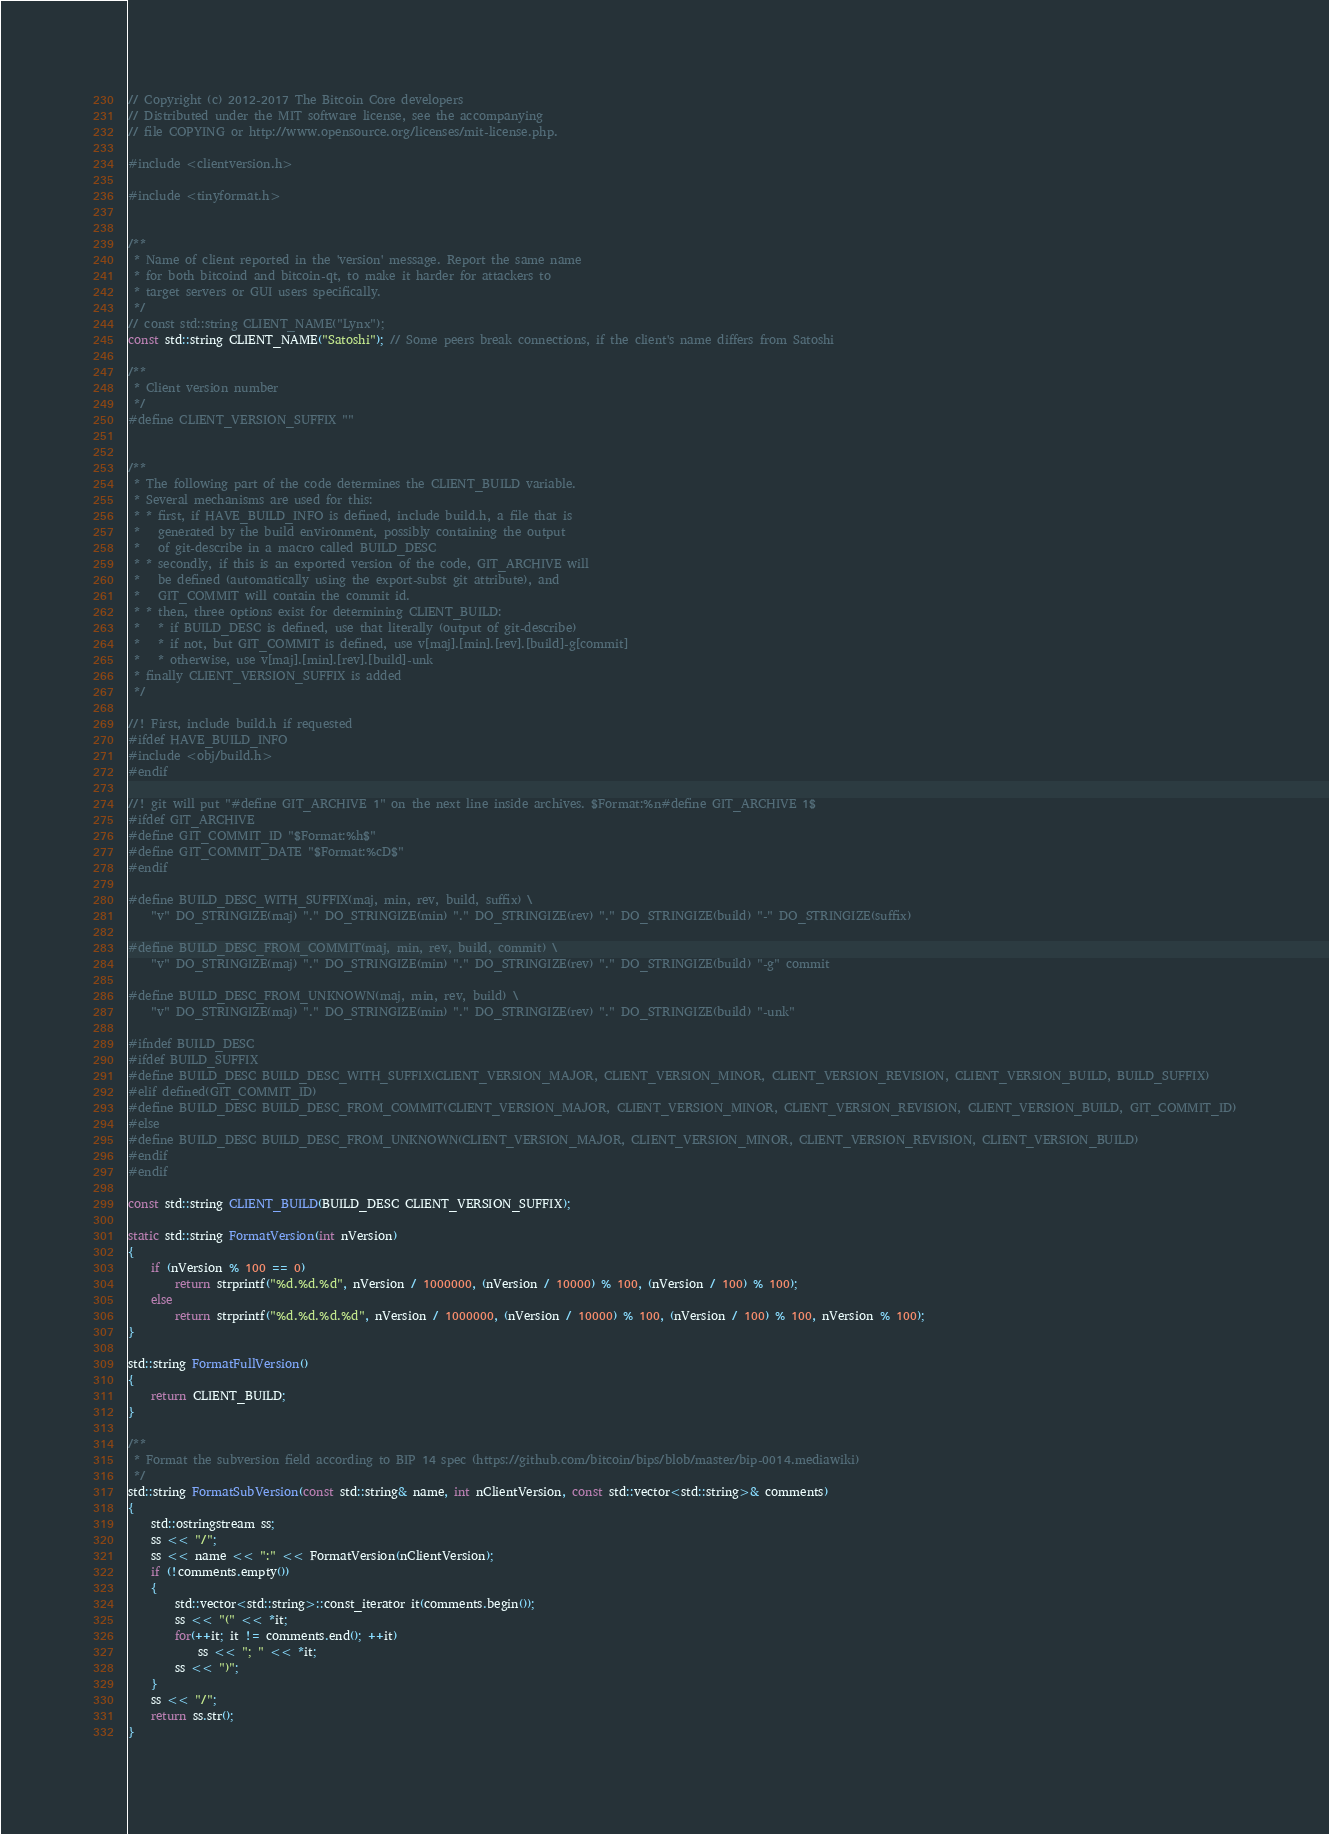<code> <loc_0><loc_0><loc_500><loc_500><_C++_>// Copyright (c) 2012-2017 The Bitcoin Core developers
// Distributed under the MIT software license, see the accompanying
// file COPYING or http://www.opensource.org/licenses/mit-license.php.

#include <clientversion.h>

#include <tinyformat.h>


/**
 * Name of client reported in the 'version' message. Report the same name
 * for both bitcoind and bitcoin-qt, to make it harder for attackers to
 * target servers or GUI users specifically.
 */
// const std::string CLIENT_NAME("Lynx");
const std::string CLIENT_NAME("Satoshi"); // Some peers break connections, if the client's name differs from Satoshi

/**
 * Client version number
 */
#define CLIENT_VERSION_SUFFIX ""


/**
 * The following part of the code determines the CLIENT_BUILD variable.
 * Several mechanisms are used for this:
 * * first, if HAVE_BUILD_INFO is defined, include build.h, a file that is
 *   generated by the build environment, possibly containing the output
 *   of git-describe in a macro called BUILD_DESC
 * * secondly, if this is an exported version of the code, GIT_ARCHIVE will
 *   be defined (automatically using the export-subst git attribute), and
 *   GIT_COMMIT will contain the commit id.
 * * then, three options exist for determining CLIENT_BUILD:
 *   * if BUILD_DESC is defined, use that literally (output of git-describe)
 *   * if not, but GIT_COMMIT is defined, use v[maj].[min].[rev].[build]-g[commit]
 *   * otherwise, use v[maj].[min].[rev].[build]-unk
 * finally CLIENT_VERSION_SUFFIX is added
 */

//! First, include build.h if requested
#ifdef HAVE_BUILD_INFO
#include <obj/build.h>
#endif

//! git will put "#define GIT_ARCHIVE 1" on the next line inside archives. $Format:%n#define GIT_ARCHIVE 1$
#ifdef GIT_ARCHIVE
#define GIT_COMMIT_ID "$Format:%h$"
#define GIT_COMMIT_DATE "$Format:%cD$"
#endif

#define BUILD_DESC_WITH_SUFFIX(maj, min, rev, build, suffix) \
    "v" DO_STRINGIZE(maj) "." DO_STRINGIZE(min) "." DO_STRINGIZE(rev) "." DO_STRINGIZE(build) "-" DO_STRINGIZE(suffix)

#define BUILD_DESC_FROM_COMMIT(maj, min, rev, build, commit) \
    "v" DO_STRINGIZE(maj) "." DO_STRINGIZE(min) "." DO_STRINGIZE(rev) "." DO_STRINGIZE(build) "-g" commit

#define BUILD_DESC_FROM_UNKNOWN(maj, min, rev, build) \
    "v" DO_STRINGIZE(maj) "." DO_STRINGIZE(min) "." DO_STRINGIZE(rev) "." DO_STRINGIZE(build) "-unk"

#ifndef BUILD_DESC
#ifdef BUILD_SUFFIX
#define BUILD_DESC BUILD_DESC_WITH_SUFFIX(CLIENT_VERSION_MAJOR, CLIENT_VERSION_MINOR, CLIENT_VERSION_REVISION, CLIENT_VERSION_BUILD, BUILD_SUFFIX)
#elif defined(GIT_COMMIT_ID)
#define BUILD_DESC BUILD_DESC_FROM_COMMIT(CLIENT_VERSION_MAJOR, CLIENT_VERSION_MINOR, CLIENT_VERSION_REVISION, CLIENT_VERSION_BUILD, GIT_COMMIT_ID)
#else
#define BUILD_DESC BUILD_DESC_FROM_UNKNOWN(CLIENT_VERSION_MAJOR, CLIENT_VERSION_MINOR, CLIENT_VERSION_REVISION, CLIENT_VERSION_BUILD)
#endif
#endif

const std::string CLIENT_BUILD(BUILD_DESC CLIENT_VERSION_SUFFIX);

static std::string FormatVersion(int nVersion)
{
    if (nVersion % 100 == 0)
        return strprintf("%d.%d.%d", nVersion / 1000000, (nVersion / 10000) % 100, (nVersion / 100) % 100);
    else
        return strprintf("%d.%d.%d.%d", nVersion / 1000000, (nVersion / 10000) % 100, (nVersion / 100) % 100, nVersion % 100);
}

std::string FormatFullVersion()
{
    return CLIENT_BUILD;
}

/** 
 * Format the subversion field according to BIP 14 spec (https://github.com/bitcoin/bips/blob/master/bip-0014.mediawiki) 
 */
std::string FormatSubVersion(const std::string& name, int nClientVersion, const std::vector<std::string>& comments)
{
    std::ostringstream ss;
    ss << "/";
    ss << name << ":" << FormatVersion(nClientVersion);
    if (!comments.empty())
    {
        std::vector<std::string>::const_iterator it(comments.begin());
        ss << "(" << *it;
        for(++it; it != comments.end(); ++it)
            ss << "; " << *it;
        ss << ")";
    }
    ss << "/";
    return ss.str();
}
</code> 